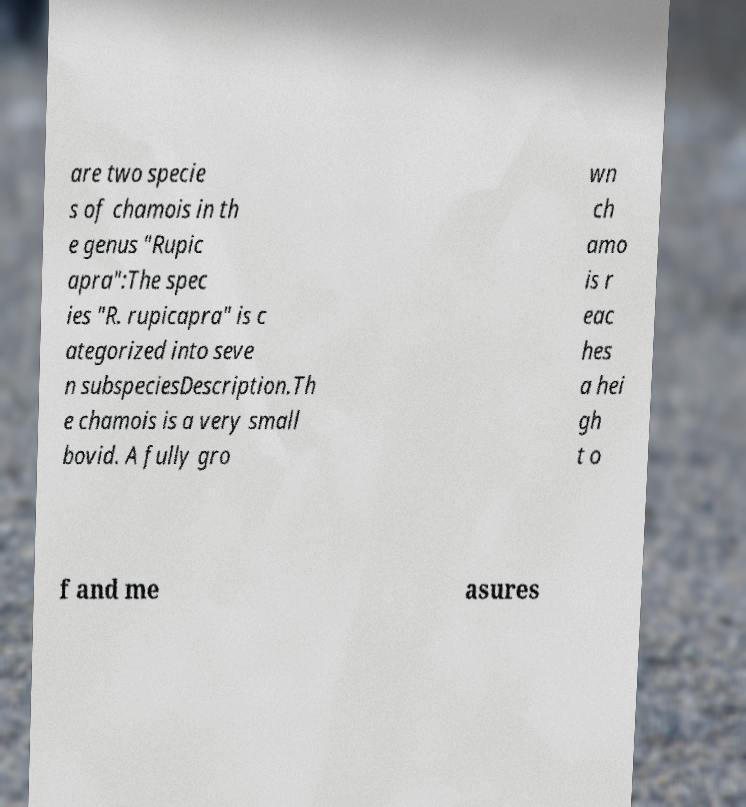I need the written content from this picture converted into text. Can you do that? are two specie s of chamois in th e genus "Rupic apra":The spec ies "R. rupicapra" is c ategorized into seve n subspeciesDescription.Th e chamois is a very small bovid. A fully gro wn ch amo is r eac hes a hei gh t o f and me asures 